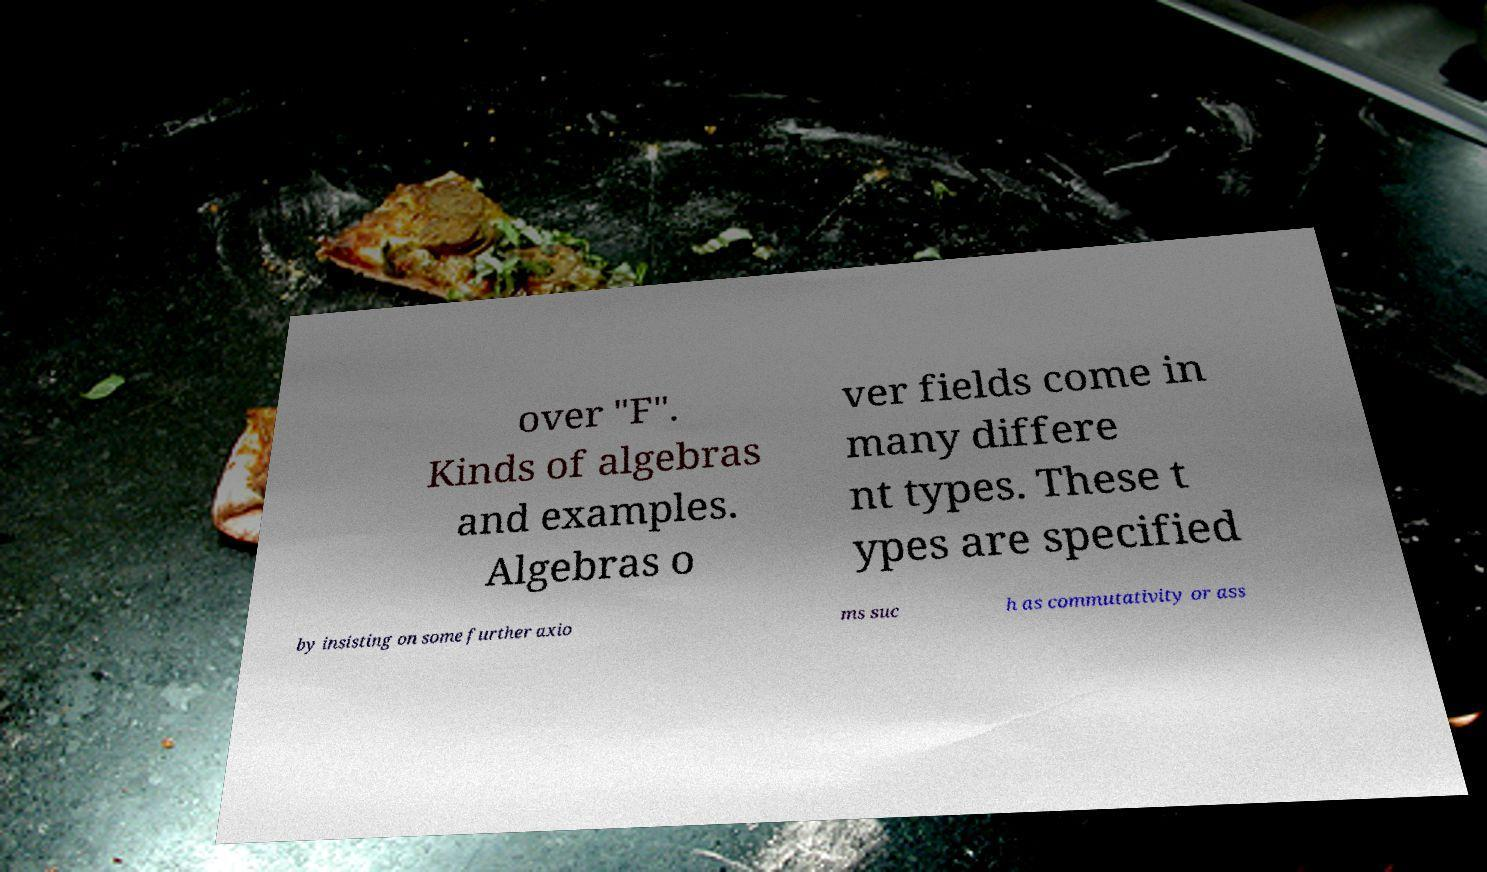Please read and relay the text visible in this image. What does it say? over "F". Kinds of algebras and examples. Algebras o ver fields come in many differe nt types. These t ypes are specified by insisting on some further axio ms suc h as commutativity or ass 